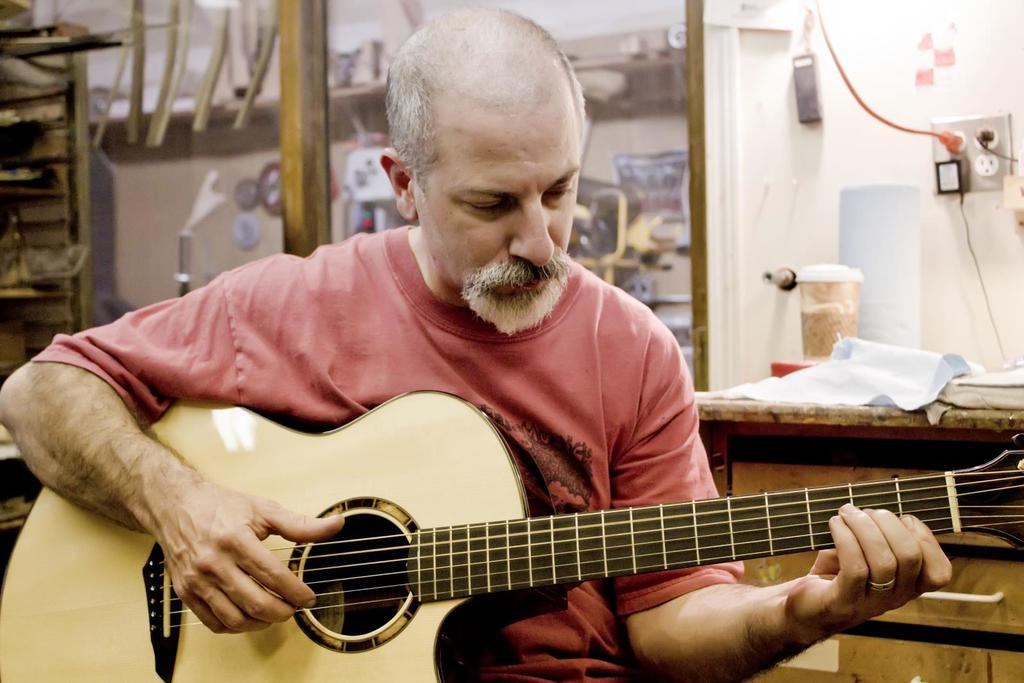What is the main subject of the image? The main subject of the image is a man. What is the man doing in the image? The man is sitting and playing a guitar. What arithmetic problem is the man solving with his mouth in the image? There is no arithmetic problem or use of the mouth in the image; the man is playing a guitar. 